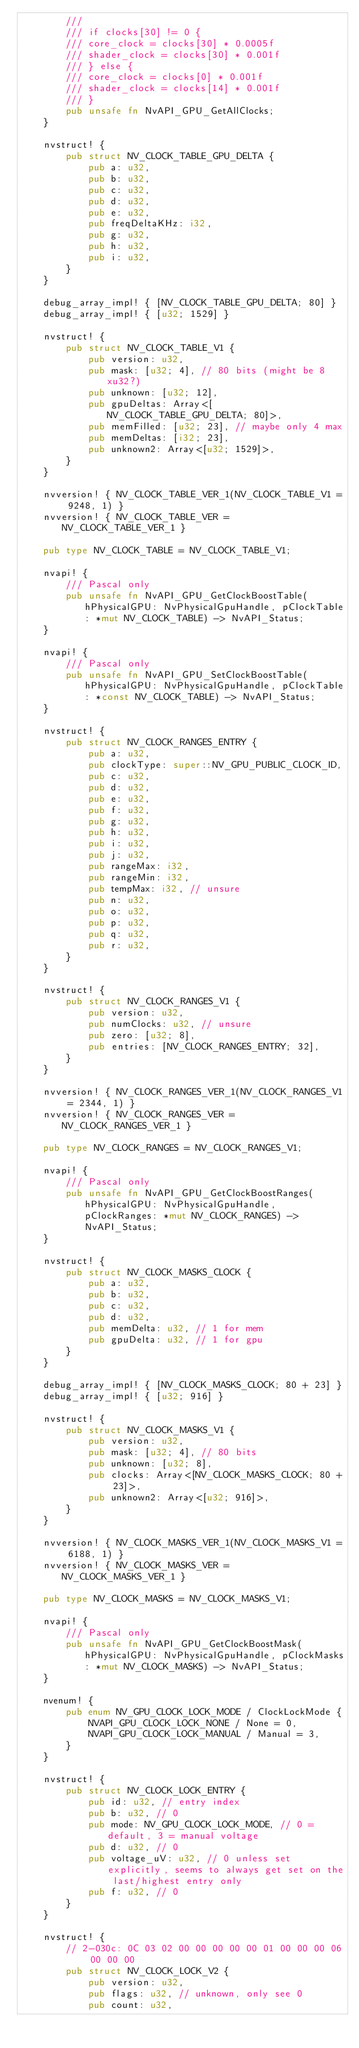Convert code to text. <code><loc_0><loc_0><loc_500><loc_500><_Rust_>        ///
        /// if clocks[30] != 0 {
        /// core_clock = clocks[30] * 0.0005f
        /// shader_clock = clocks[30] * 0.001f
        /// } else {
        /// core_clock = clocks[0] * 0.001f
        /// shader_clock = clocks[14] * 0.001f
        /// }
        pub unsafe fn NvAPI_GPU_GetAllClocks;
    }

    nvstruct! {
        pub struct NV_CLOCK_TABLE_GPU_DELTA {
            pub a: u32,
            pub b: u32,
            pub c: u32,
            pub d: u32,
            pub e: u32,
            pub freqDeltaKHz: i32,
            pub g: u32,
            pub h: u32,
            pub i: u32,
        }
    }

    debug_array_impl! { [NV_CLOCK_TABLE_GPU_DELTA; 80] }
    debug_array_impl! { [u32; 1529] }

    nvstruct! {
        pub struct NV_CLOCK_TABLE_V1 {
            pub version: u32,
            pub mask: [u32; 4], // 80 bits (might be 8xu32?)
            pub unknown: [u32; 12],
            pub gpuDeltas: Array<[NV_CLOCK_TABLE_GPU_DELTA; 80]>,
            pub memFilled: [u32; 23], // maybe only 4 max
            pub memDeltas: [i32; 23],
            pub unknown2: Array<[u32; 1529]>,
        }
    }

    nvversion! { NV_CLOCK_TABLE_VER_1(NV_CLOCK_TABLE_V1 = 9248, 1) }
    nvversion! { NV_CLOCK_TABLE_VER = NV_CLOCK_TABLE_VER_1 }

    pub type NV_CLOCK_TABLE = NV_CLOCK_TABLE_V1;

    nvapi! {
        /// Pascal only
        pub unsafe fn NvAPI_GPU_GetClockBoostTable(hPhysicalGPU: NvPhysicalGpuHandle, pClockTable: *mut NV_CLOCK_TABLE) -> NvAPI_Status;
    }

    nvapi! {
        /// Pascal only
        pub unsafe fn NvAPI_GPU_SetClockBoostTable(hPhysicalGPU: NvPhysicalGpuHandle, pClockTable: *const NV_CLOCK_TABLE) -> NvAPI_Status;
    }

    nvstruct! {
        pub struct NV_CLOCK_RANGES_ENTRY {
            pub a: u32,
            pub clockType: super::NV_GPU_PUBLIC_CLOCK_ID,
            pub c: u32,
            pub d: u32,
            pub e: u32,
            pub f: u32,
            pub g: u32,
            pub h: u32,
            pub i: u32,
            pub j: u32,
            pub rangeMax: i32,
            pub rangeMin: i32,
            pub tempMax: i32, // unsure
            pub n: u32,
            pub o: u32,
            pub p: u32,
            pub q: u32,
            pub r: u32,
        }
    }

    nvstruct! {
        pub struct NV_CLOCK_RANGES_V1 {
            pub version: u32,
            pub numClocks: u32, // unsure
            pub zero: [u32; 8],
            pub entries: [NV_CLOCK_RANGES_ENTRY; 32],
        }
    }

    nvversion! { NV_CLOCK_RANGES_VER_1(NV_CLOCK_RANGES_V1 = 2344, 1) }
    nvversion! { NV_CLOCK_RANGES_VER = NV_CLOCK_RANGES_VER_1 }

    pub type NV_CLOCK_RANGES = NV_CLOCK_RANGES_V1;

    nvapi! {
        /// Pascal only
        pub unsafe fn NvAPI_GPU_GetClockBoostRanges(hPhysicalGPU: NvPhysicalGpuHandle, pClockRanges: *mut NV_CLOCK_RANGES) -> NvAPI_Status;
    }

    nvstruct! {
        pub struct NV_CLOCK_MASKS_CLOCK {
            pub a: u32,
            pub b: u32,
            pub c: u32,
            pub d: u32,
            pub memDelta: u32, // 1 for mem
            pub gpuDelta: u32, // 1 for gpu
        }
    }

    debug_array_impl! { [NV_CLOCK_MASKS_CLOCK; 80 + 23] }
    debug_array_impl! { [u32; 916] }

    nvstruct! {
        pub struct NV_CLOCK_MASKS_V1 {
            pub version: u32,
            pub mask: [u32; 4], // 80 bits
            pub unknown: [u32; 8],
            pub clocks: Array<[NV_CLOCK_MASKS_CLOCK; 80 + 23]>,
            pub unknown2: Array<[u32; 916]>,
        }
    }

    nvversion! { NV_CLOCK_MASKS_VER_1(NV_CLOCK_MASKS_V1 = 6188, 1) }
    nvversion! { NV_CLOCK_MASKS_VER = NV_CLOCK_MASKS_VER_1 }

    pub type NV_CLOCK_MASKS = NV_CLOCK_MASKS_V1;

    nvapi! {
        /// Pascal only
        pub unsafe fn NvAPI_GPU_GetClockBoostMask(hPhysicalGPU: NvPhysicalGpuHandle, pClockMasks: *mut NV_CLOCK_MASKS) -> NvAPI_Status;
    }

    nvenum! {
        pub enum NV_GPU_CLOCK_LOCK_MODE / ClockLockMode {
            NVAPI_GPU_CLOCK_LOCK_NONE / None = 0,
            NVAPI_GPU_CLOCK_LOCK_MANUAL / Manual = 3,
        }
    }

    nvstruct! {
        pub struct NV_CLOCK_LOCK_ENTRY {
            pub id: u32, // entry index
            pub b: u32, // 0
            pub mode: NV_GPU_CLOCK_LOCK_MODE, // 0 = default, 3 = manual voltage
            pub d: u32, // 0
            pub voltage_uV: u32, // 0 unless set explicitly, seems to always get set on the last/highest entry only
            pub f: u32, // 0
        }
    }

    nvstruct! {
        // 2-030c: 0C 03 02 00 00 00 00 00 01 00 00 00 06 00 00 00
        pub struct NV_CLOCK_LOCK_V2 {
            pub version: u32,
            pub flags: u32, // unknown, only see 0
            pub count: u32,</code> 